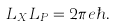<formula> <loc_0><loc_0><loc_500><loc_500>L _ { X } L _ { P } = 2 \pi e \hbar { . }</formula> 